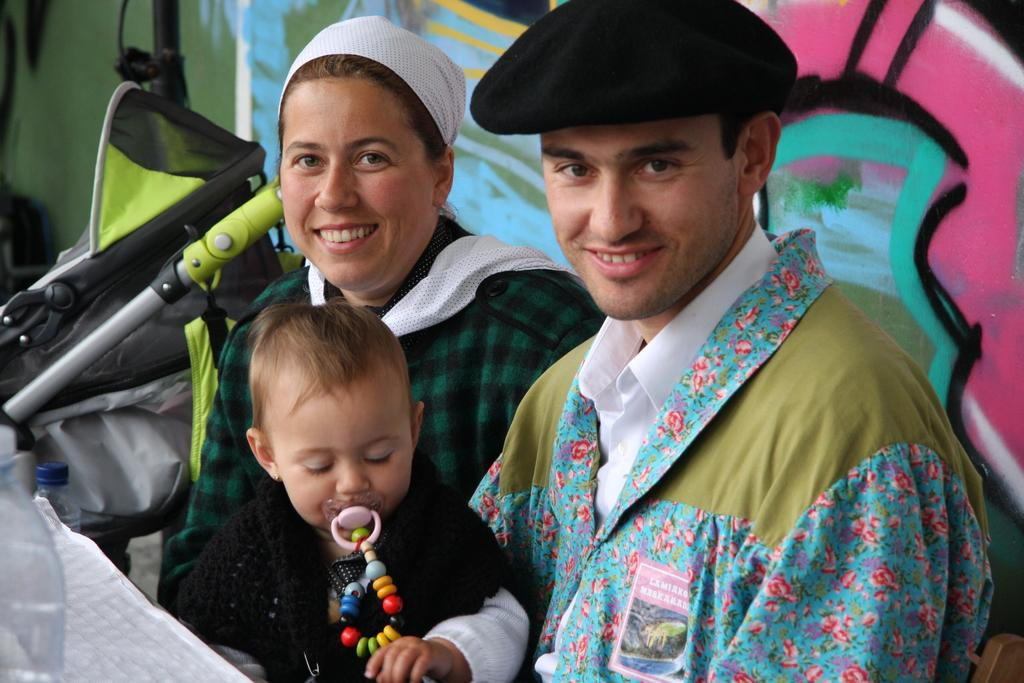How many people are in the image? There are two persons and a child in the image. What are the persons and child doing in the image? The persons and child are sitting. What object related to children is present in the image? There is a stroller in the image. What colors can be seen on the stroller? The stroller is black, green, and grey in color. What can be observed about the background of the image? There is a colorful background in the image. Can you tell me how the monkey is using the whip in the image? There is no monkey or whip present in the image. How does the earthquake affect the persons and child in the image? There is no earthquake depicted in the image; the persons and child are sitting calmly. 